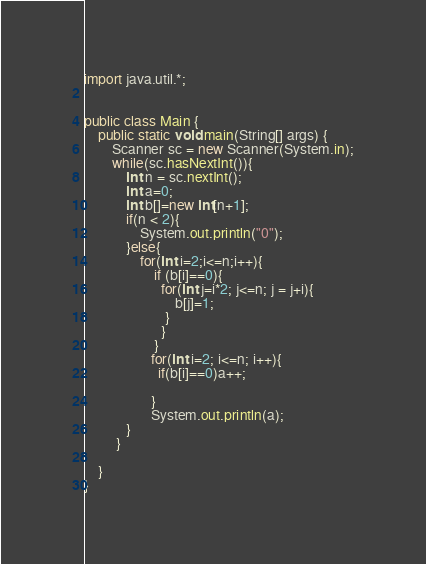Convert code to text. <code><loc_0><loc_0><loc_500><loc_500><_Java_>import java.util.*;
 
 
public class Main {
    public static void main(String[] args) {
        Scanner sc = new Scanner(System.in);
        while(sc.hasNextInt()){
            int n = sc.nextInt();
            int a=0;
            int b[]=new int[n+1];
            if(n < 2){
                System.out.println("0");
            }else{
                for(int i=2;i<=n;i++){
                    if (b[i]==0){
                      for(int j=i*2; j<=n; j = j+i){
                          b[j]=1;
                       }
                      }        
                    }
                   for(int i=2; i<=n; i++){
                     if(b[i]==0)a++;
                   
                   }
                   System.out.println(a);
            }
         }
             
    }
}</code> 